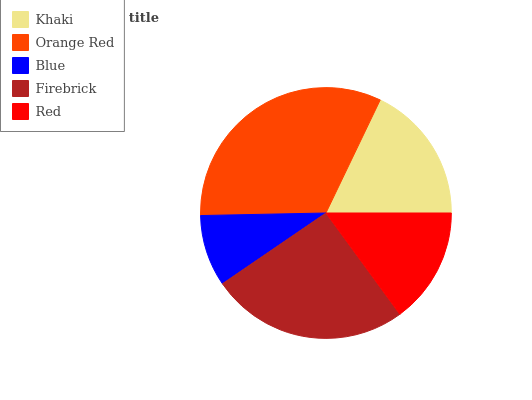Is Blue the minimum?
Answer yes or no. Yes. Is Orange Red the maximum?
Answer yes or no. Yes. Is Orange Red the minimum?
Answer yes or no. No. Is Blue the maximum?
Answer yes or no. No. Is Orange Red greater than Blue?
Answer yes or no. Yes. Is Blue less than Orange Red?
Answer yes or no. Yes. Is Blue greater than Orange Red?
Answer yes or no. No. Is Orange Red less than Blue?
Answer yes or no. No. Is Khaki the high median?
Answer yes or no. Yes. Is Khaki the low median?
Answer yes or no. Yes. Is Blue the high median?
Answer yes or no. No. Is Firebrick the low median?
Answer yes or no. No. 